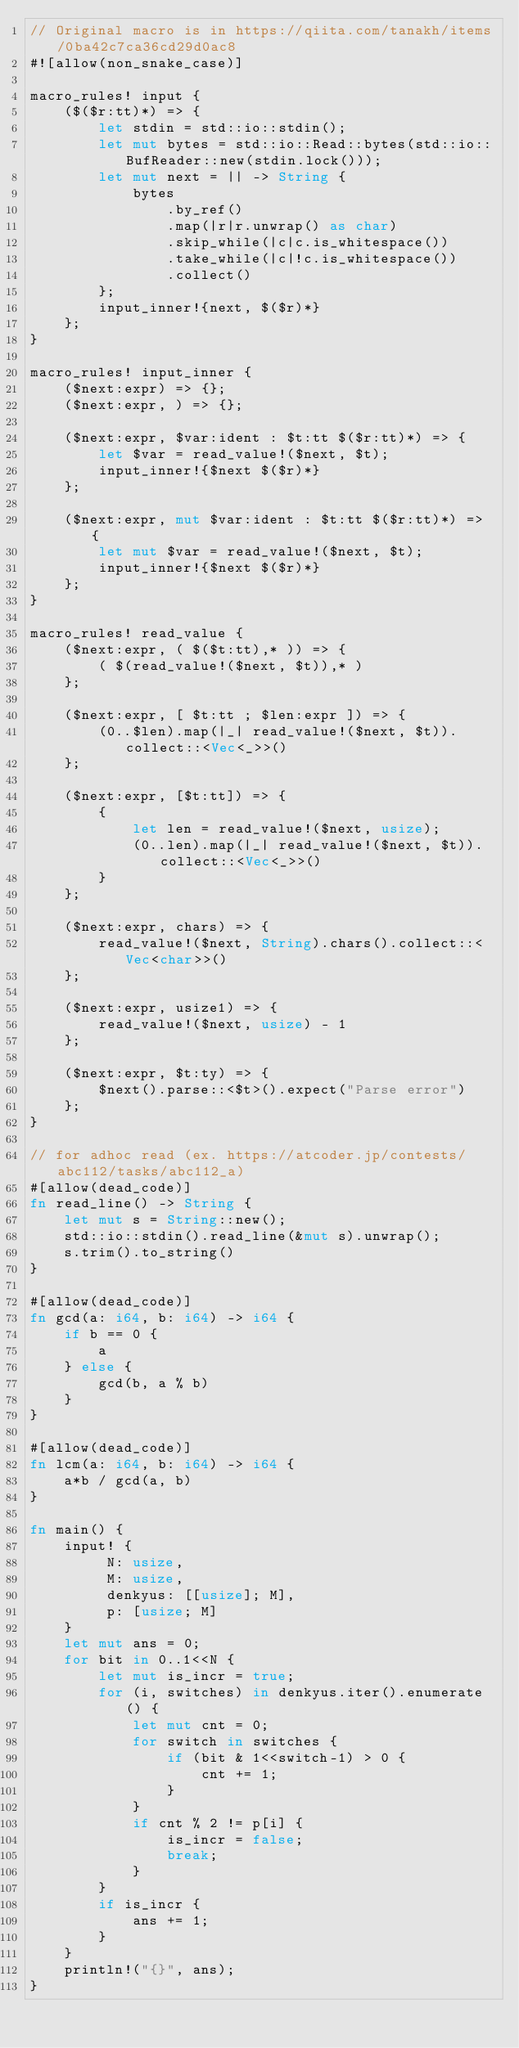Convert code to text. <code><loc_0><loc_0><loc_500><loc_500><_Rust_>// Original macro is in https://qiita.com/tanakh/items/0ba42c7ca36cd29d0ac8
#![allow(non_snake_case)]

macro_rules! input {
    ($($r:tt)*) => {
        let stdin = std::io::stdin();
        let mut bytes = std::io::Read::bytes(std::io::BufReader::new(stdin.lock()));
        let mut next = || -> String {
            bytes
                .by_ref()
                .map(|r|r.unwrap() as char)
                .skip_while(|c|c.is_whitespace())
                .take_while(|c|!c.is_whitespace())
                .collect()
        };
        input_inner!{next, $($r)*}
    };
}
 
macro_rules! input_inner {
    ($next:expr) => {};
    ($next:expr, ) => {};
 
    ($next:expr, $var:ident : $t:tt $($r:tt)*) => {
        let $var = read_value!($next, $t);
        input_inner!{$next $($r)*}
    };
    
    ($next:expr, mut $var:ident : $t:tt $($r:tt)*) => {
        let mut $var = read_value!($next, $t);
        input_inner!{$next $($r)*}
    };
}
 
macro_rules! read_value {
    ($next:expr, ( $($t:tt),* )) => {
        ( $(read_value!($next, $t)),* )
    };
 
    ($next:expr, [ $t:tt ; $len:expr ]) => {
        (0..$len).map(|_| read_value!($next, $t)).collect::<Vec<_>>()
    };

    ($next:expr, [$t:tt]) => {
        {
            let len = read_value!($next, usize);
            (0..len).map(|_| read_value!($next, $t)).collect::<Vec<_>>()
        }
    };
 
    ($next:expr, chars) => {
        read_value!($next, String).chars().collect::<Vec<char>>()
    };
 
    ($next:expr, usize1) => {
        read_value!($next, usize) - 1
    };
 
    ($next:expr, $t:ty) => {
        $next().parse::<$t>().expect("Parse error")
    };
}

// for adhoc read (ex. https://atcoder.jp/contests/abc112/tasks/abc112_a)
#[allow(dead_code)]
fn read_line() -> String {
    let mut s = String::new();
    std::io::stdin().read_line(&mut s).unwrap();
    s.trim().to_string()
}

#[allow(dead_code)]
fn gcd(a: i64, b: i64) -> i64 {
    if b == 0 {
        a
    } else {
        gcd(b, a % b)
    }
}

#[allow(dead_code)]
fn lcm(a: i64, b: i64) -> i64 {
    a*b / gcd(a, b)
}

fn main() {
    input! { 
         N: usize, 
         M: usize,
         denkyus: [[usize]; M],
         p: [usize; M]
    }
    let mut ans = 0; 
    for bit in 0..1<<N {
        let mut is_incr = true;
        for (i, switches) in denkyus.iter().enumerate() {
            let mut cnt = 0;
            for switch in switches {
                if (bit & 1<<switch-1) > 0 {
                    cnt += 1;
                }
            }
            if cnt % 2 != p[i] {
                is_incr = false;
                break;
            }
        }
        if is_incr {
            ans += 1;
        }
    }
    println!("{}", ans);
}
</code> 